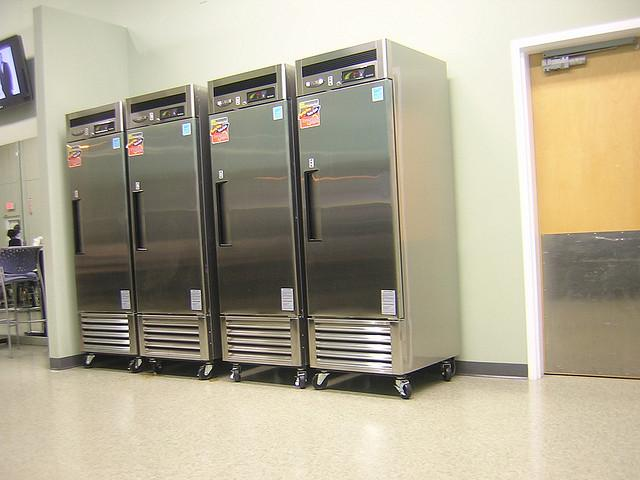What temperature do these devices keep things?

Choices:
A) hot
B) boiling
C) cold
D) room cold 